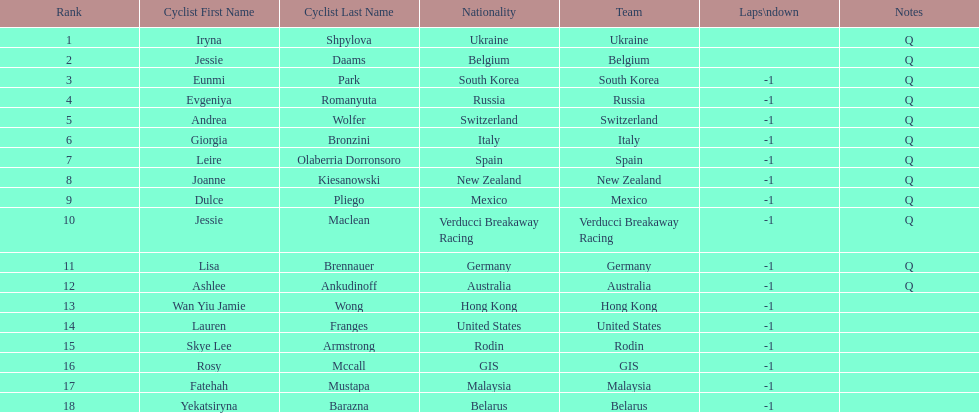What team is listed previous to belgium? Ukraine. 